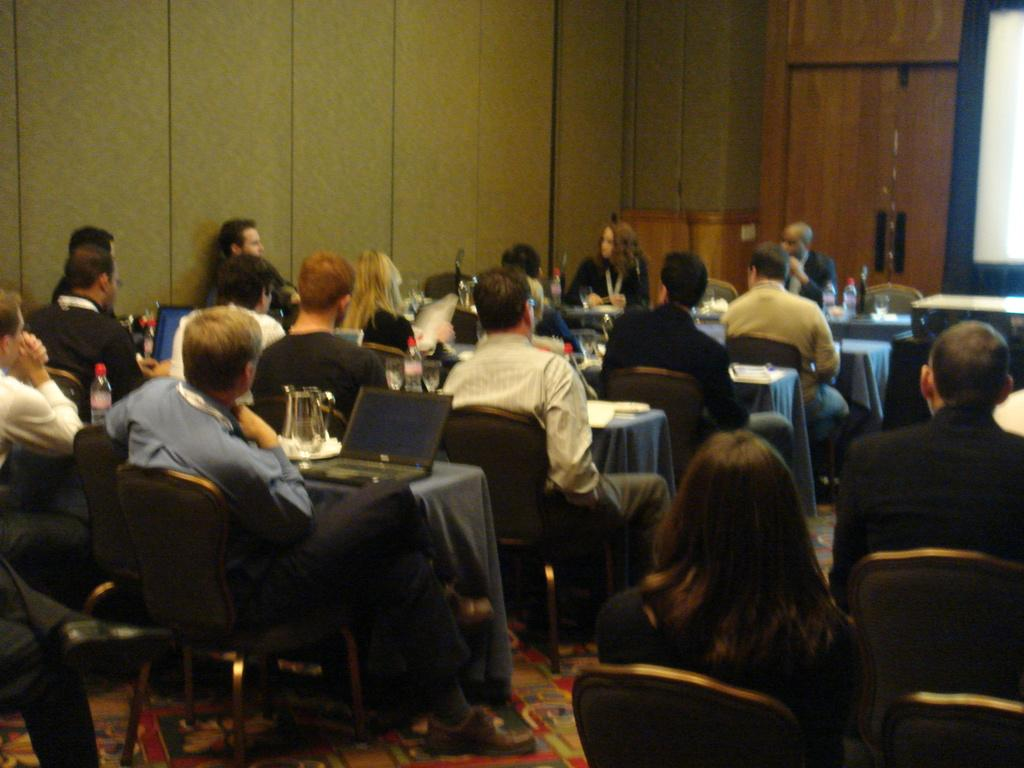What are the people in the image doing? The people in the image are sitting on chairs. What furniture is present in the image besides chairs? There are tables in the image. What electronic device can be seen on a table in the image? There is a laptop on a table in the image. What type of sand can be seen on the island in the image? There is no sand or island present in the image; it features people sitting on chairs and tables with a laptop. 